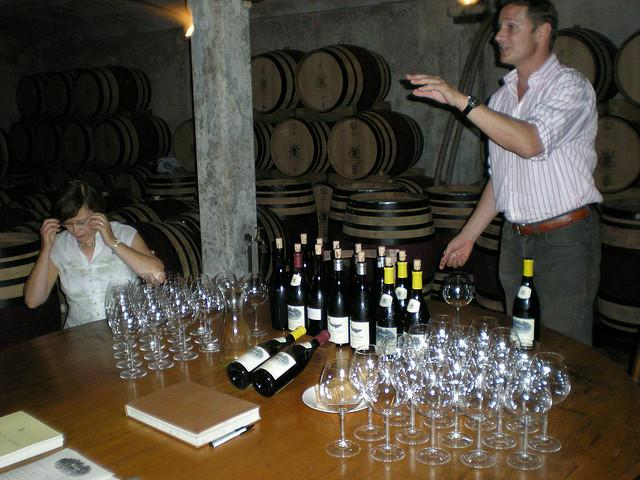What kind of wood is used to make the barrels in the background?

Choices:
A) mahogany
B) oak
C) birch
D) pine oak 